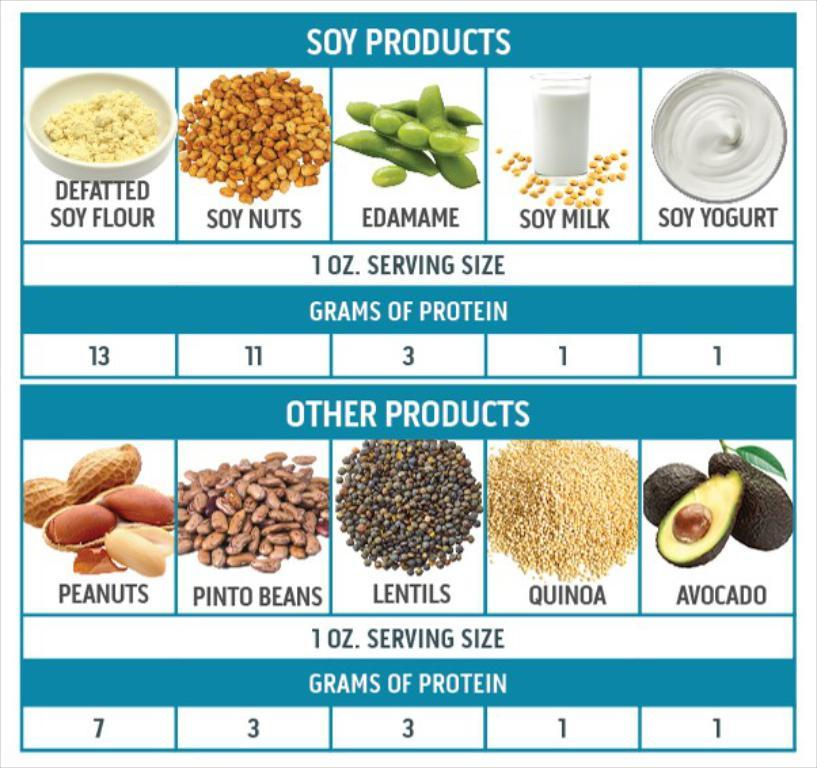What type of images can be seen in the image? There are images of pulses in the image. What else is present in the image besides the images of pulses? There is text and numbers written in the image. What type of fruit is being held by the person in the image? There is no person or fruit present in the image; it only contains images of pulses, text, and numbers. 